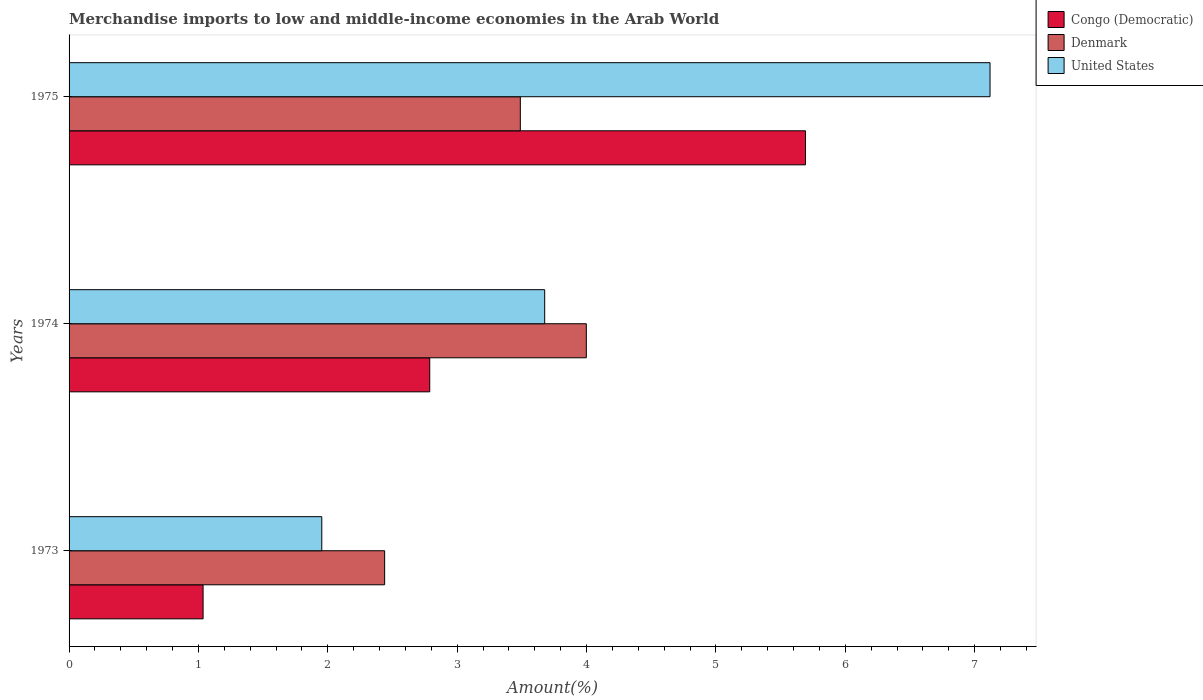Are the number of bars per tick equal to the number of legend labels?
Provide a succinct answer. Yes. What is the label of the 1st group of bars from the top?
Your response must be concise. 1975. In how many cases, is the number of bars for a given year not equal to the number of legend labels?
Provide a succinct answer. 0. What is the percentage of amount earned from merchandise imports in Congo (Democratic) in 1973?
Offer a very short reply. 1.04. Across all years, what is the maximum percentage of amount earned from merchandise imports in United States?
Keep it short and to the point. 7.12. Across all years, what is the minimum percentage of amount earned from merchandise imports in United States?
Offer a terse response. 1.95. In which year was the percentage of amount earned from merchandise imports in Denmark maximum?
Make the answer very short. 1974. In which year was the percentage of amount earned from merchandise imports in Congo (Democratic) minimum?
Give a very brief answer. 1973. What is the total percentage of amount earned from merchandise imports in Denmark in the graph?
Provide a short and direct response. 9.93. What is the difference between the percentage of amount earned from merchandise imports in Congo (Democratic) in 1974 and that in 1975?
Offer a terse response. -2.9. What is the difference between the percentage of amount earned from merchandise imports in Denmark in 1973 and the percentage of amount earned from merchandise imports in United States in 1975?
Provide a short and direct response. -4.68. What is the average percentage of amount earned from merchandise imports in United States per year?
Ensure brevity in your answer.  4.25. In the year 1975, what is the difference between the percentage of amount earned from merchandise imports in United States and percentage of amount earned from merchandise imports in Denmark?
Make the answer very short. 3.63. In how many years, is the percentage of amount earned from merchandise imports in Denmark greater than 3.8 %?
Keep it short and to the point. 1. What is the ratio of the percentage of amount earned from merchandise imports in Congo (Democratic) in 1973 to that in 1974?
Keep it short and to the point. 0.37. Is the percentage of amount earned from merchandise imports in United States in 1974 less than that in 1975?
Provide a short and direct response. Yes. What is the difference between the highest and the second highest percentage of amount earned from merchandise imports in Denmark?
Offer a terse response. 0.51. What is the difference between the highest and the lowest percentage of amount earned from merchandise imports in Denmark?
Provide a short and direct response. 1.56. What does the 1st bar from the top in 1974 represents?
Ensure brevity in your answer.  United States. What does the 1st bar from the bottom in 1975 represents?
Keep it short and to the point. Congo (Democratic). Is it the case that in every year, the sum of the percentage of amount earned from merchandise imports in Denmark and percentage of amount earned from merchandise imports in United States is greater than the percentage of amount earned from merchandise imports in Congo (Democratic)?
Offer a very short reply. Yes. Are all the bars in the graph horizontal?
Offer a very short reply. Yes. What is the difference between two consecutive major ticks on the X-axis?
Offer a very short reply. 1. Are the values on the major ticks of X-axis written in scientific E-notation?
Provide a short and direct response. No. Where does the legend appear in the graph?
Your answer should be very brief. Top right. How are the legend labels stacked?
Your response must be concise. Vertical. What is the title of the graph?
Provide a succinct answer. Merchandise imports to low and middle-income economies in the Arab World. Does "Nigeria" appear as one of the legend labels in the graph?
Your response must be concise. No. What is the label or title of the X-axis?
Offer a terse response. Amount(%). What is the label or title of the Y-axis?
Offer a terse response. Years. What is the Amount(%) in Congo (Democratic) in 1973?
Offer a very short reply. 1.04. What is the Amount(%) in Denmark in 1973?
Make the answer very short. 2.44. What is the Amount(%) in United States in 1973?
Make the answer very short. 1.95. What is the Amount(%) in Congo (Democratic) in 1974?
Your answer should be compact. 2.79. What is the Amount(%) of Denmark in 1974?
Your answer should be compact. 4. What is the Amount(%) in United States in 1974?
Ensure brevity in your answer.  3.68. What is the Amount(%) in Congo (Democratic) in 1975?
Provide a short and direct response. 5.69. What is the Amount(%) of Denmark in 1975?
Give a very brief answer. 3.49. What is the Amount(%) in United States in 1975?
Your response must be concise. 7.12. Across all years, what is the maximum Amount(%) of Congo (Democratic)?
Your response must be concise. 5.69. Across all years, what is the maximum Amount(%) of Denmark?
Offer a very short reply. 4. Across all years, what is the maximum Amount(%) in United States?
Your answer should be compact. 7.12. Across all years, what is the minimum Amount(%) in Congo (Democratic)?
Offer a very short reply. 1.04. Across all years, what is the minimum Amount(%) in Denmark?
Keep it short and to the point. 2.44. Across all years, what is the minimum Amount(%) of United States?
Your answer should be very brief. 1.95. What is the total Amount(%) in Congo (Democratic) in the graph?
Provide a short and direct response. 9.52. What is the total Amount(%) in Denmark in the graph?
Keep it short and to the point. 9.93. What is the total Amount(%) of United States in the graph?
Your response must be concise. 12.75. What is the difference between the Amount(%) in Congo (Democratic) in 1973 and that in 1974?
Your response must be concise. -1.75. What is the difference between the Amount(%) in Denmark in 1973 and that in 1974?
Give a very brief answer. -1.56. What is the difference between the Amount(%) of United States in 1973 and that in 1974?
Ensure brevity in your answer.  -1.72. What is the difference between the Amount(%) of Congo (Democratic) in 1973 and that in 1975?
Provide a short and direct response. -4.66. What is the difference between the Amount(%) of Denmark in 1973 and that in 1975?
Provide a succinct answer. -1.05. What is the difference between the Amount(%) in United States in 1973 and that in 1975?
Provide a succinct answer. -5.17. What is the difference between the Amount(%) of Congo (Democratic) in 1974 and that in 1975?
Ensure brevity in your answer.  -2.9. What is the difference between the Amount(%) of Denmark in 1974 and that in 1975?
Your answer should be very brief. 0.51. What is the difference between the Amount(%) of United States in 1974 and that in 1975?
Provide a succinct answer. -3.44. What is the difference between the Amount(%) in Congo (Democratic) in 1973 and the Amount(%) in Denmark in 1974?
Keep it short and to the point. -2.96. What is the difference between the Amount(%) of Congo (Democratic) in 1973 and the Amount(%) of United States in 1974?
Ensure brevity in your answer.  -2.64. What is the difference between the Amount(%) in Denmark in 1973 and the Amount(%) in United States in 1974?
Provide a short and direct response. -1.24. What is the difference between the Amount(%) of Congo (Democratic) in 1973 and the Amount(%) of Denmark in 1975?
Your response must be concise. -2.45. What is the difference between the Amount(%) of Congo (Democratic) in 1973 and the Amount(%) of United States in 1975?
Provide a succinct answer. -6.08. What is the difference between the Amount(%) in Denmark in 1973 and the Amount(%) in United States in 1975?
Your response must be concise. -4.68. What is the difference between the Amount(%) in Congo (Democratic) in 1974 and the Amount(%) in Denmark in 1975?
Provide a short and direct response. -0.7. What is the difference between the Amount(%) of Congo (Democratic) in 1974 and the Amount(%) of United States in 1975?
Offer a very short reply. -4.33. What is the difference between the Amount(%) in Denmark in 1974 and the Amount(%) in United States in 1975?
Give a very brief answer. -3.12. What is the average Amount(%) in Congo (Democratic) per year?
Make the answer very short. 3.17. What is the average Amount(%) of Denmark per year?
Your answer should be very brief. 3.31. What is the average Amount(%) of United States per year?
Your answer should be compact. 4.25. In the year 1973, what is the difference between the Amount(%) of Congo (Democratic) and Amount(%) of Denmark?
Offer a very short reply. -1.4. In the year 1973, what is the difference between the Amount(%) in Congo (Democratic) and Amount(%) in United States?
Provide a short and direct response. -0.92. In the year 1973, what is the difference between the Amount(%) of Denmark and Amount(%) of United States?
Offer a very short reply. 0.49. In the year 1974, what is the difference between the Amount(%) in Congo (Democratic) and Amount(%) in Denmark?
Offer a terse response. -1.21. In the year 1974, what is the difference between the Amount(%) in Congo (Democratic) and Amount(%) in United States?
Your response must be concise. -0.89. In the year 1974, what is the difference between the Amount(%) in Denmark and Amount(%) in United States?
Ensure brevity in your answer.  0.32. In the year 1975, what is the difference between the Amount(%) of Congo (Democratic) and Amount(%) of Denmark?
Give a very brief answer. 2.2. In the year 1975, what is the difference between the Amount(%) in Congo (Democratic) and Amount(%) in United States?
Your answer should be very brief. -1.43. In the year 1975, what is the difference between the Amount(%) in Denmark and Amount(%) in United States?
Provide a short and direct response. -3.63. What is the ratio of the Amount(%) in Congo (Democratic) in 1973 to that in 1974?
Offer a very short reply. 0.37. What is the ratio of the Amount(%) in Denmark in 1973 to that in 1974?
Provide a succinct answer. 0.61. What is the ratio of the Amount(%) in United States in 1973 to that in 1974?
Your answer should be compact. 0.53. What is the ratio of the Amount(%) of Congo (Democratic) in 1973 to that in 1975?
Provide a short and direct response. 0.18. What is the ratio of the Amount(%) of Denmark in 1973 to that in 1975?
Keep it short and to the point. 0.7. What is the ratio of the Amount(%) in United States in 1973 to that in 1975?
Offer a very short reply. 0.27. What is the ratio of the Amount(%) of Congo (Democratic) in 1974 to that in 1975?
Provide a short and direct response. 0.49. What is the ratio of the Amount(%) of Denmark in 1974 to that in 1975?
Ensure brevity in your answer.  1.15. What is the ratio of the Amount(%) of United States in 1974 to that in 1975?
Your response must be concise. 0.52. What is the difference between the highest and the second highest Amount(%) in Congo (Democratic)?
Provide a succinct answer. 2.9. What is the difference between the highest and the second highest Amount(%) of Denmark?
Your answer should be compact. 0.51. What is the difference between the highest and the second highest Amount(%) in United States?
Keep it short and to the point. 3.44. What is the difference between the highest and the lowest Amount(%) in Congo (Democratic)?
Your answer should be very brief. 4.66. What is the difference between the highest and the lowest Amount(%) of Denmark?
Provide a short and direct response. 1.56. What is the difference between the highest and the lowest Amount(%) of United States?
Offer a terse response. 5.17. 